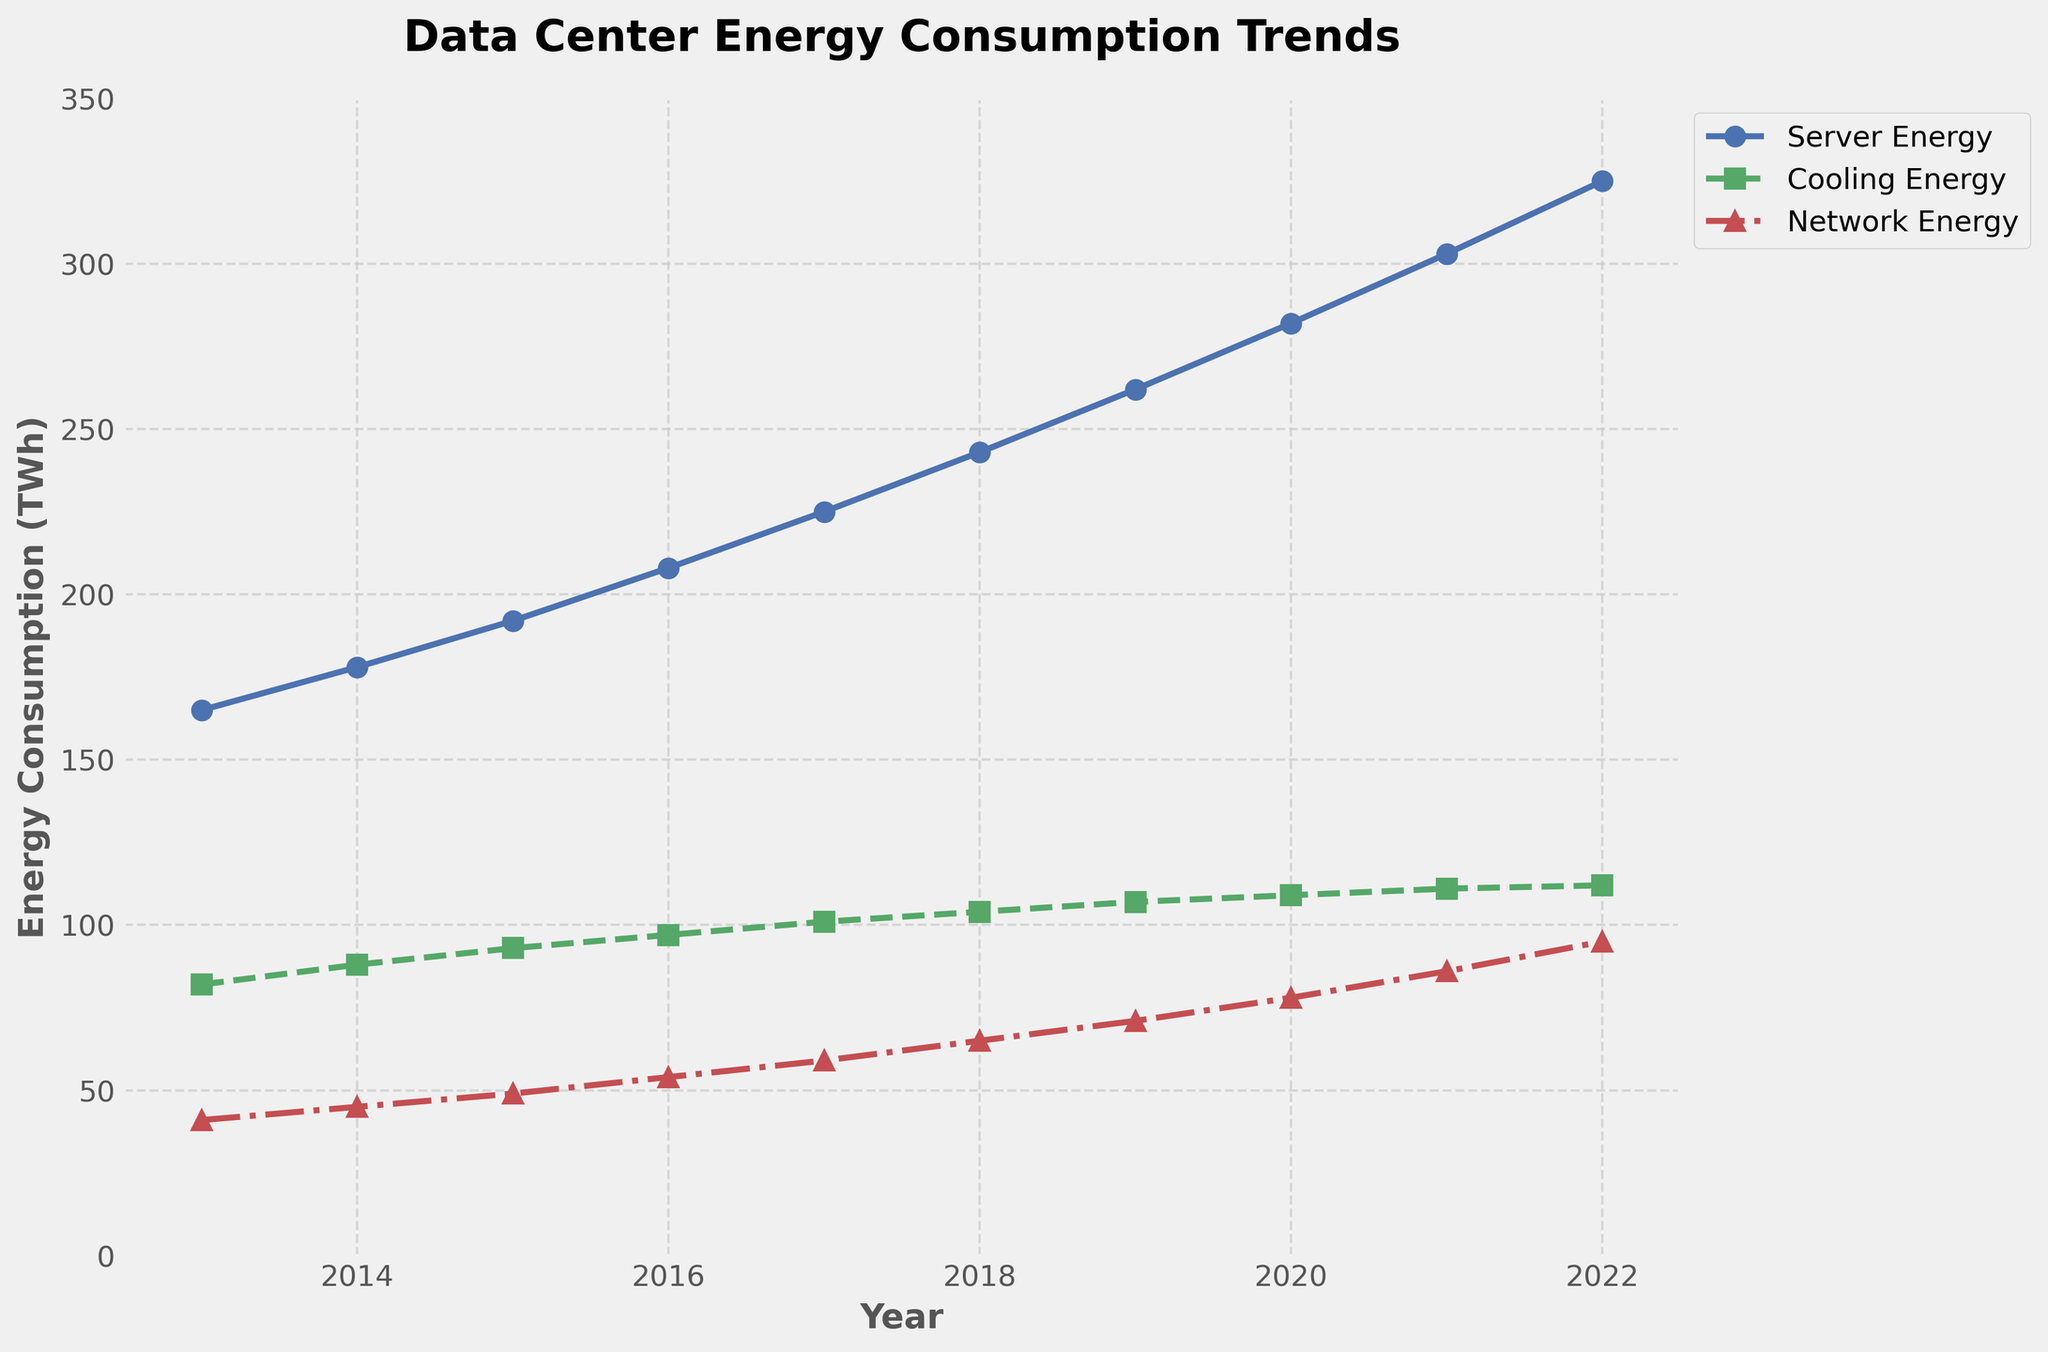What was the trend of server energy consumption from 2013 to 2022? The server energy consumption increased steadily each year from 2013 to 2022. In 2013, the consumption was 165 TWh and it reached 325 TWh in 2022.
Answer: Steady increase Between which consecutive years did cooling energy consumption increase the most? The cooling energy consumption increased by the largest amount between 2013 and 2014, where it went from 82 TWh to 88 TWh, an increase of 6 TWh.
Answer: 2013-2014 What is the total energy consumption of all components in 2022? In 2022, the total energy consumption is the sum of server, cooling, and network energy consumption: 325 (server) + 112 (cooling) + 95 (network) = 532 TWh.
Answer: 532 TWh How does the network energy consumption in 2020 compare to 2015? Network energy consumption in 2020 was 78 TWh whereas in 2015 it was 49 TWh, so 2020 had 29 TWh more.
Answer: 29 TWh more What is the average cooling energy consumption over the decade? To find the average cooling energy consumption: (82 + 88 + 93 + 97 + 101 + 104 + 107 + 109 + 111 + 112) / 10 = 1004 / 10 = 100.4 TWh.
Answer: 100.4 TWh How did the trend of network energy consumption change from 2019 to 2021? From 2019 to 2021, the network energy consumption increased from 71 TWh to 86 TWh.
Answer: Increase Which component had the highest energy consumption in 2015? In 2015, server energy consumption was 192 TWh, cooling was 93 TWh, and network was 49 TWh. The highest is server energy consumption.
Answer: Server What is the sum of server and cooling energy consumption in 2018? Summing server and cooling energy consumption in 2018: 243 (server) + 104 (cooling) = 347 TWh.
Answer: 347 TWh Is the rate of increase in network energy consumption consistent over the decade? The network energy consumption shows a generally increasing trend, but the rate of increase is not consistent. It varies slightly over the years.
Answer: Not consistent How many years did it take for the server energy consumption to almost double from its 2013 value? From 2013's value of 165 TWh, server energy nearly doubled by 2022 with a consumption of 325 TWh. This took 9 years.
Answer: 9 years 